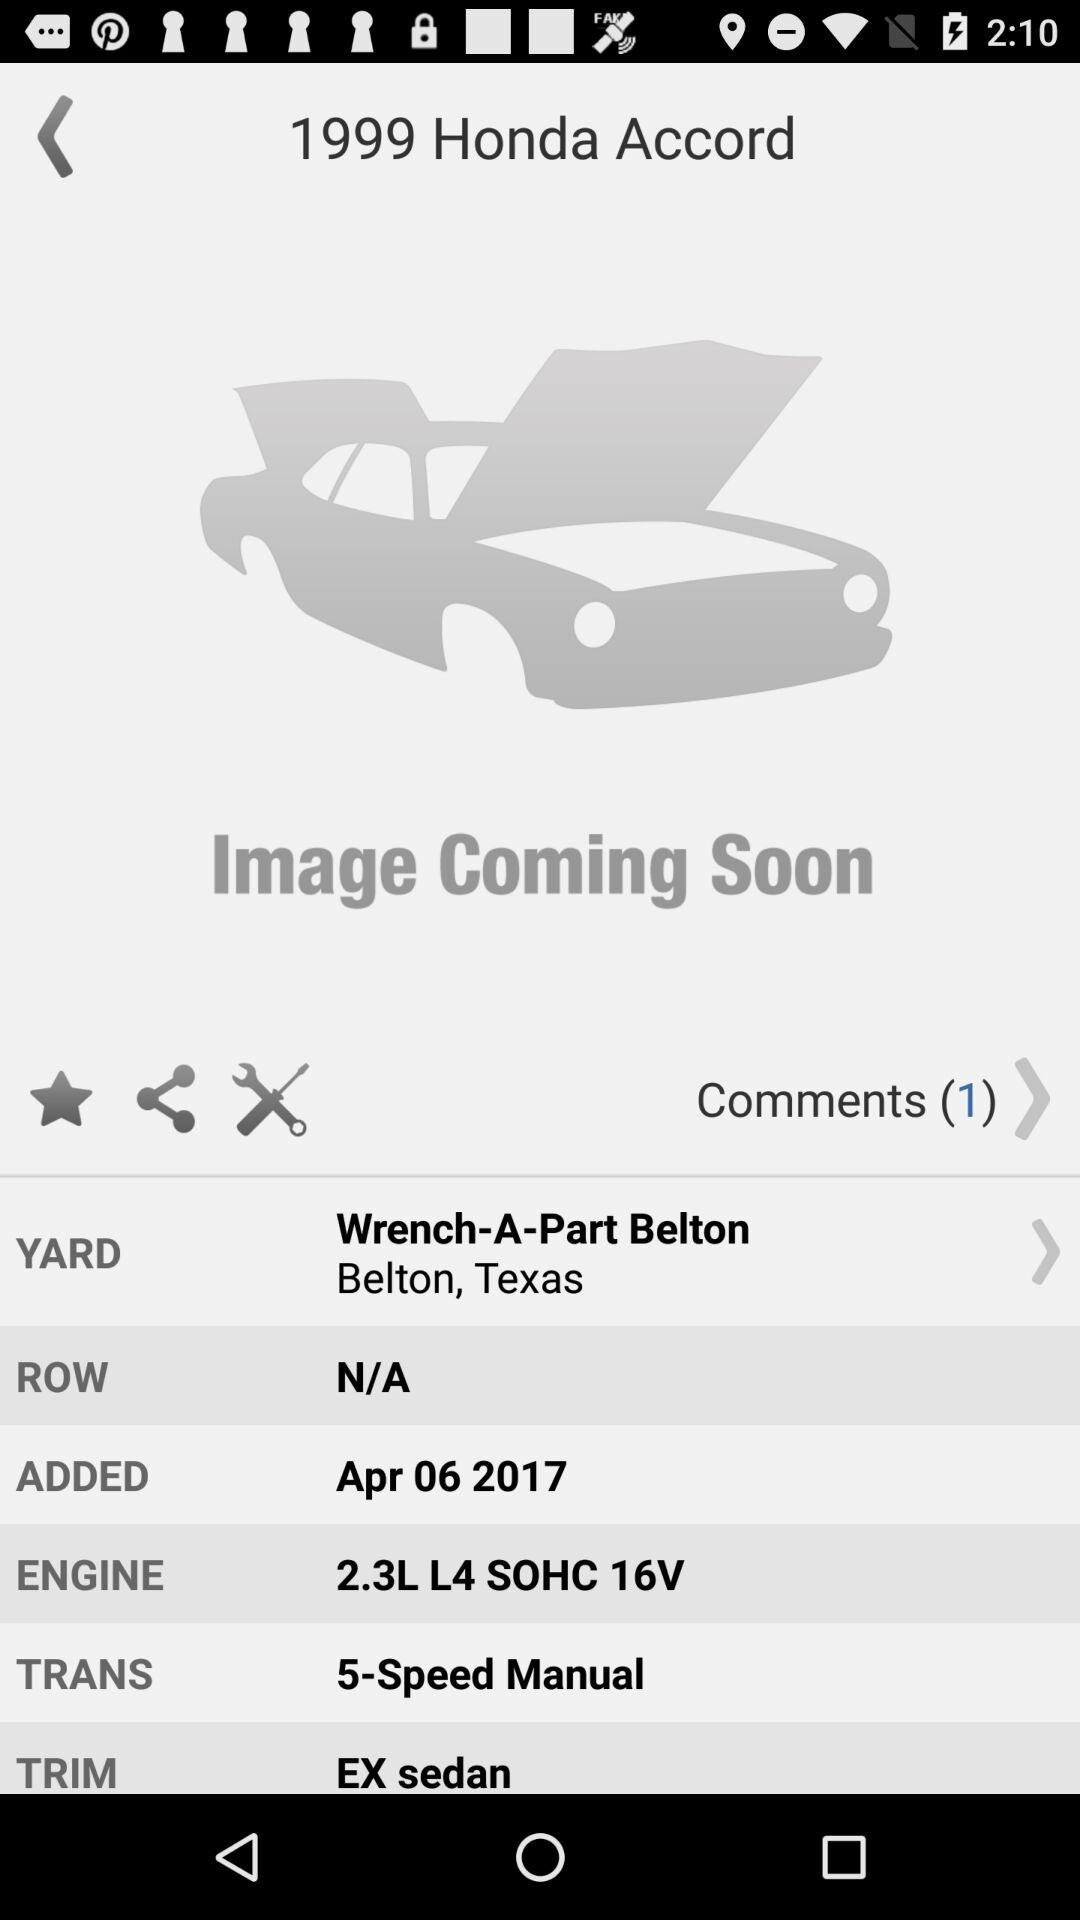What is the yard name? The yard name is "Wrench-A-Part Belton, Belton, Texas". 